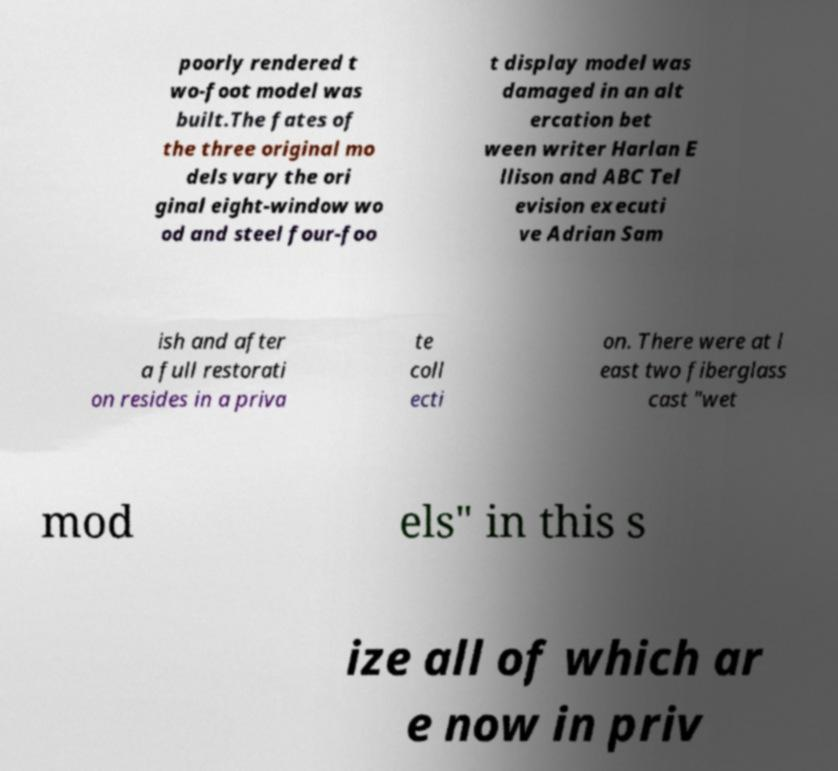Could you extract and type out the text from this image? poorly rendered t wo-foot model was built.The fates of the three original mo dels vary the ori ginal eight-window wo od and steel four-foo t display model was damaged in an alt ercation bet ween writer Harlan E llison and ABC Tel evision executi ve Adrian Sam ish and after a full restorati on resides in a priva te coll ecti on. There were at l east two fiberglass cast "wet mod els" in this s ize all of which ar e now in priv 